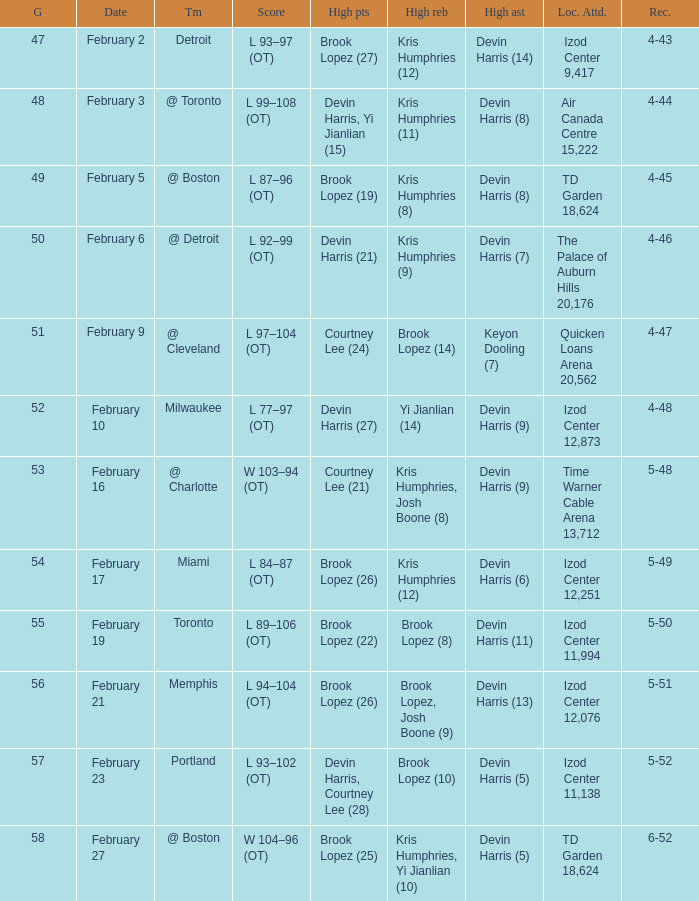What was the score of the game in which Brook Lopez (8) did the high rebounds? L 89–106 (OT). 